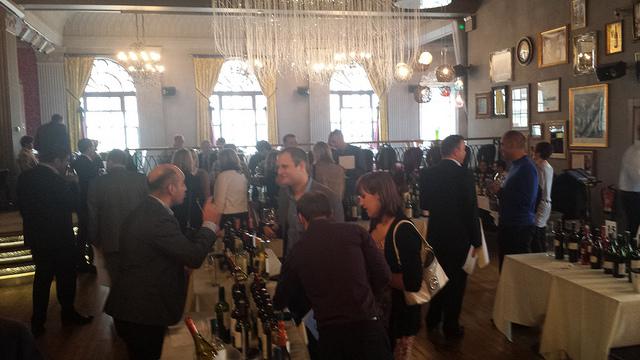What time of day is it?
Short answer required. Afternoon. Is this an indoor scene?
Concise answer only. Yes. Formal or informal?
Answer briefly. Formal. Are most these people wearing leather jackets?
Write a very short answer. No. Is it daytime?
Be succinct. Yes. Are these people waiting at an airport?
Answer briefly. No. How many people are in the photo?
Give a very brief answer. 26. Is this photo in color?
Keep it brief. Yes. What are the people standing around with?
Answer briefly. Wine. Is the woman in the picture wearing sunglasses?
Short answer required. No. What would you call this type of store?
Quick response, please. Wine tasting. What type of animals are gathering together?
Be succinct. Humans. 